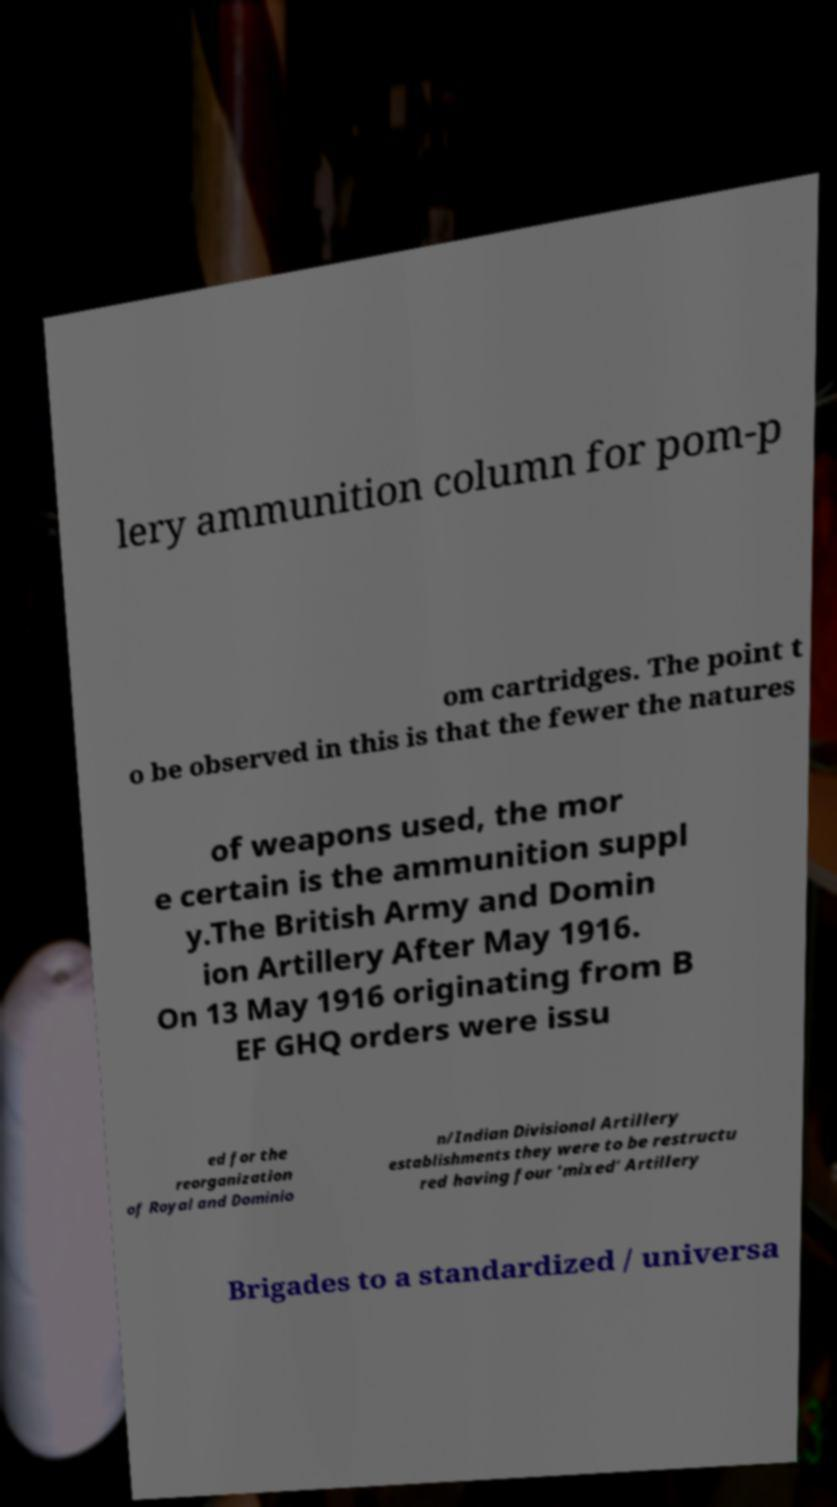Please identify and transcribe the text found in this image. lery ammunition column for pom-p om cartridges. The point t o be observed in this is that the fewer the natures of weapons used, the mor e certain is the ammunition suppl y.The British Army and Domin ion Artillery After May 1916. On 13 May 1916 originating from B EF GHQ orders were issu ed for the reorganization of Royal and Dominio n/Indian Divisional Artillery establishments they were to be restructu red having four ‘mixed’ Artillery Brigades to a standardized / universa 